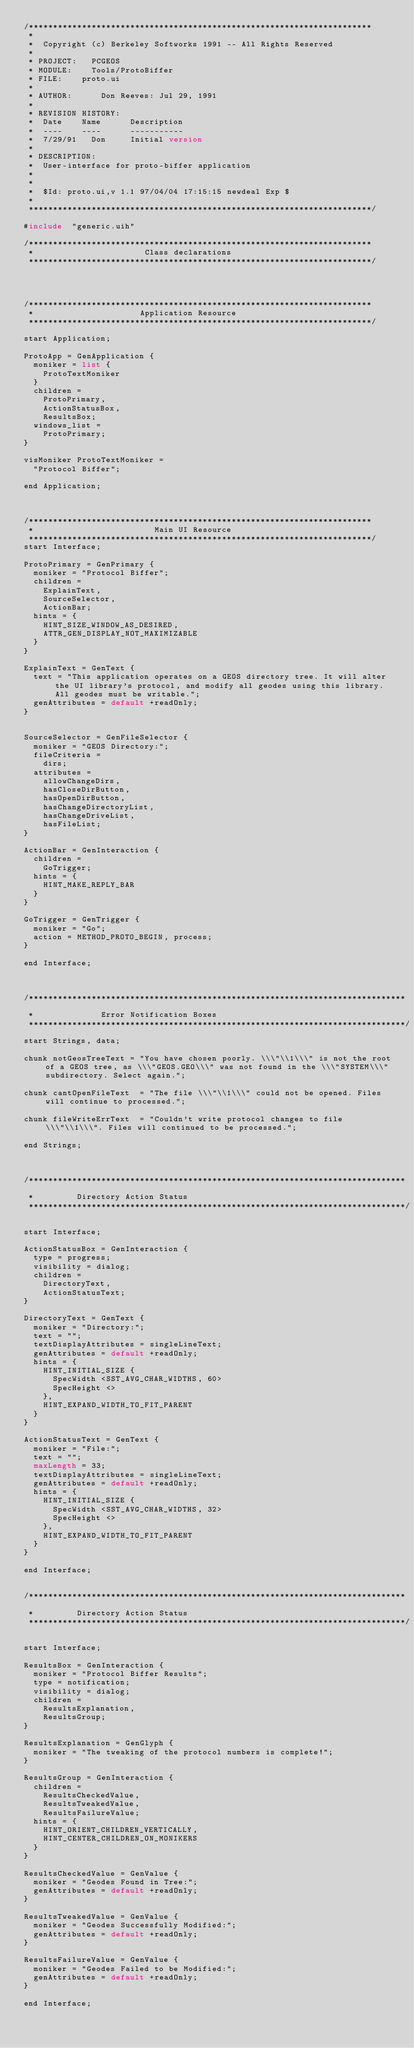Convert code to text. <code><loc_0><loc_0><loc_500><loc_500><_XML_>/***********************************************************************
 *
 *	Copyright (c) Berkeley Softworks 1991 -- All Rights Reserved
 *
 * PROJECT:	  PCGEOS
 * MODULE:	  Tools/ProtoBiffer
 * FILE:	  proto.ui
 *
 * AUTHOR:  	  Don Reeves: Jul 29, 1991
 *
 * REVISION HISTORY:
 *	Date	  Name	    Description
 *	----	  ----	    -----------
 *	7/29/91	  Don	    Initial version
 *
 * DESCRIPTION:
 *	User-interface for proto-biffer application
 *
 *
 * 	$Id: proto.ui,v 1.1 97/04/04 17:15:15 newdeal Exp $
 *
 ***********************************************************************/

#include	"generic.uih"

/***********************************************************************
 *                       Class declarations
 ***********************************************************************/




/***********************************************************************
 *                      Application Resource
 ***********************************************************************/

start Application;

ProtoApp = GenApplication {
	moniker = list {
		ProtoTextMoniker
	}
	children =
		ProtoPrimary,
		ActionStatusBox,
		ResultsBox;
	windows_list =
		ProtoPrimary;
}

visMoniker ProtoTextMoniker =
	"Protocol Biffer";

end Application;



/***********************************************************************
 *                         Main UI Resource
 ***********************************************************************/
start Interface;

ProtoPrimary = GenPrimary {
	moniker = "Protocol Biffer";
	children =
		ExplainText,
		SourceSelector,
		ActionBar;
	hints = {
		HINT_SIZE_WINDOW_AS_DESIRED,
		ATTR_GEN_DISPLAY_NOT_MAXIMIZABLE
	}
}

ExplainText = GenText {
	text = "This application operates on a GEOS directory tree. It will alter the UI library's protocol, and modify all geodes using this library. All geodes must be writable.";
	genAttributes = default +readOnly;
}


SourceSelector = GenFileSelector {
	moniker = "GEOS Directory:";
	fileCriteria =
		dirs;
	attributes = 
		allowChangeDirs,
		hasCloseDirButton,
		hasOpenDirButton,
		hasChangeDirectoryList,
		hasChangeDriveList,
		hasFileList;
}

ActionBar = GenInteraction {
	children = 
		GoTrigger;
	hints = {
		HINT_MAKE_REPLY_BAR
	}
}

GoTrigger = GenTrigger {
	moniker = "Go";
	action = METHOD_PROTO_BEGIN, process;
}

end	Interface;



/******************************************************************************
 *		          Error Notification Boxes
 ******************************************************************************/
start	Strings, data;

chunk notGeosTreeText	= "You have chosen poorly. \\\"\\1\\\" is not the root of a GEOS tree, as \\\"GEOS.GEO\\\" was not found in the \\\"SYSTEM\\\" subdirectory. Select again.";

chunk cantOpenFileText	= "The file \\\"\\1\\\" could not be opened. Files will continue to processed.";

chunk fileWriteErrText	= "Couldn't write protocol changes to file \\\"\\1\\\". Files will continued to be processed.";

end	Strings;



/******************************************************************************
 *			   Directory Action Status
 ******************************************************************************/

start	Interface;

ActionStatusBox = GenInteraction {
	type = progress;
	visibility = dialog;
	children =
		DirectoryText,
		ActionStatusText;
}

DirectoryText = GenText {
	moniker = "Directory:";
	text = "";
	textDisplayAttributes = singleLineText;
	genAttributes = default +readOnly;
	hints = {
		HINT_INITIAL_SIZE {
			SpecWidth <SST_AVG_CHAR_WIDTHS, 60>
			SpecHeight <>
		},
		HINT_EXPAND_WIDTH_TO_FIT_PARENT
	}
}

ActionStatusText = GenText {
	moniker = "File:";
	text = "";
	maxLength = 33;
	textDisplayAttributes = singleLineText;
	genAttributes = default +readOnly;
	hints = {
		HINT_INITIAL_SIZE {
			SpecWidth <SST_AVG_CHAR_WIDTHS, 32>
			SpecHeight <>
		},
		HINT_EXPAND_WIDTH_TO_FIT_PARENT
	}
}

end Interface;


/******************************************************************************
 *			   Directory Action Status
 ******************************************************************************/

start	Interface;

ResultsBox = GenInteraction {
	moniker = "Protocol Biffer Results";
	type = notification;
	visibility = dialog;
	children =
		ResultsExplanation,
		ResultsGroup;
}

ResultsExplanation = GenGlyph {
	moniker = "The tweaking of the protocol numbers is complete!";
}

ResultsGroup = GenInteraction {
	children =
		ResultsCheckedValue,
		ResultsTweakedValue,
		ResultsFailureValue;
	hints = {
		HINT_ORIENT_CHILDREN_VERTICALLY,
		HINT_CENTER_CHILDREN_ON_MONIKERS
	}	      
}

ResultsCheckedValue = GenValue {
	moniker = "Geodes Found in Tree:";
	genAttributes = default +readOnly;
}

ResultsTweakedValue = GenValue {
	moniker = "Geodes Successfully Modified:";
	genAttributes = default +readOnly;
}

ResultsFailureValue = GenValue {
	moniker = "Geodes Failed to be Modified:";
	genAttributes = default +readOnly;
}

end Interface;
</code> 